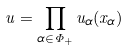<formula> <loc_0><loc_0><loc_500><loc_500>u = \prod _ { \alpha \in \Phi _ { + } } u _ { \alpha } ( x _ { \alpha } )</formula> 